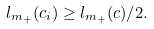<formula> <loc_0><loc_0><loc_500><loc_500>l _ { m _ { + } } ( c _ { i } ) \geq l _ { m _ { + } } ( c ) / 2 .</formula> 